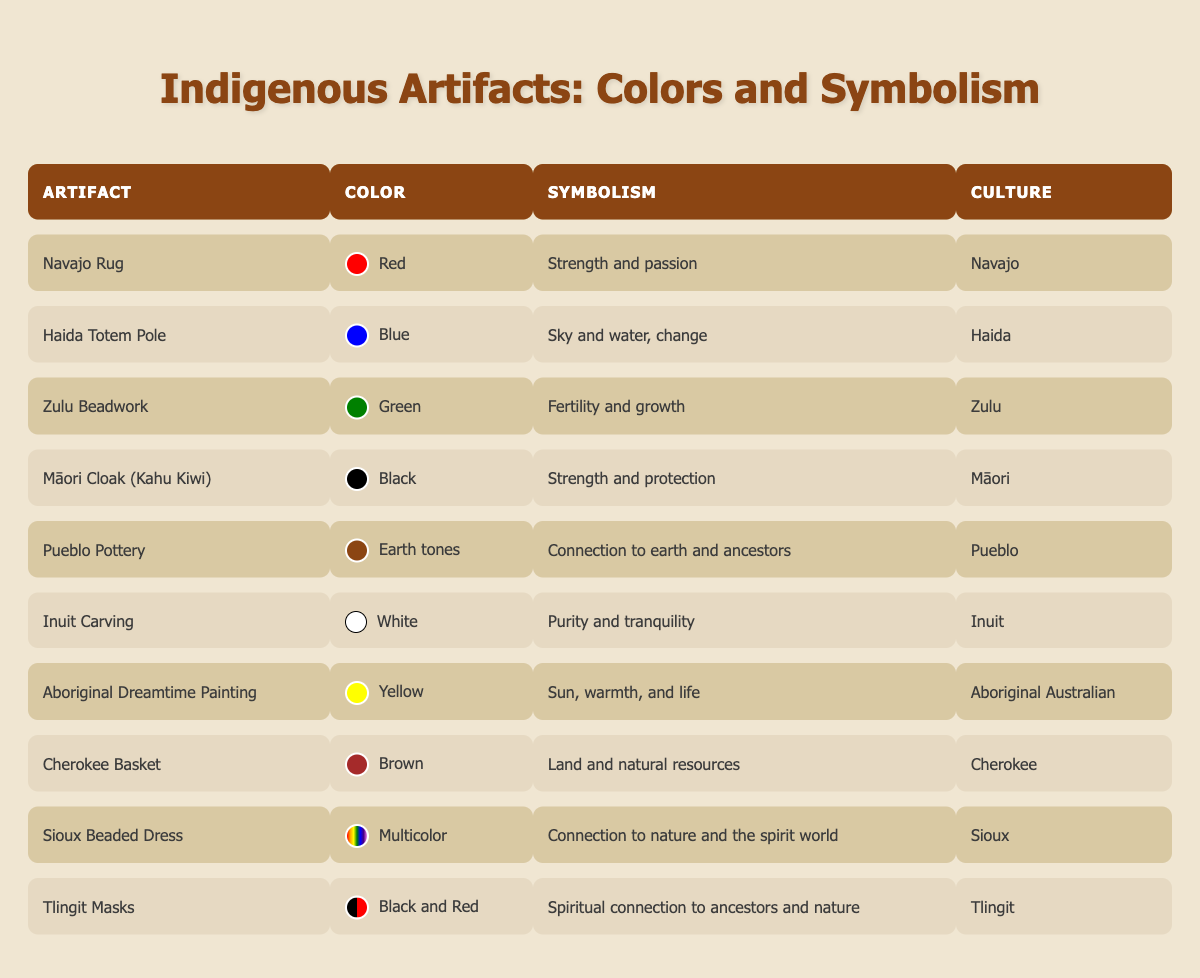What is the symbolism of the Zulu Beadwork? According to the table, the Zulu Beadwork's symbolism is "Fertility and growth."
Answer: Fertility and growth Which culture does the Māori Cloak belong to? The table indicates that the Māori Cloak (Kahu Kiwi) belongs to the Māori culture.
Answer: Māori What materials are used in the Inuit Carving? The table shows that the materials used in the Inuit Carving are either "Ivory or stone."
Answer: Ivory or stone Is the Navajo Rug used for ceremonial purposes? The table states that the Navajo Rug is used for "Blanket, ceremonial purposes," confirming that it is indeed used for ceremonial purposes.
Answer: Yes Which artifact's color symbolizes connection to earth and ancestors? The table reveals that Pueblo Pottery has the color "Earth tones," which symbolizes "Connection to earth and ancestors."
Answer: Pueblo Pottery How many different colors are represented in the artifacts? By counting the unique colors listed in the table, we have Red, Blue, Green, Black, Earth tones, White, Yellow, Brown, Multicolor, and Black and Red, giving a total of 10 distinct colors.
Answer: 10 What is the primary use of the Haida Totem Pole? The table indicates that the Haida Totem Pole is primarily used for "Cultural storytelling, memorialization."
Answer: Cultural storytelling, memorialization Which artifact has the symbolism related to the spirit world? The Sioux Beaded Dress symbolizes a "Connection to nature and the spirit world" as stated in the table.
Answer: Sioux Beaded Dress What color is associated with the Aboriginal Dreamtime Painting? The table shows that the Aboriginal Dreamtime Painting is associated with the color "Yellow."
Answer: Yellow Do both the Tlingit Masks and the Māori Cloak represent strength? The Tlingit Masks symbolize "Spiritual connection to ancestors and nature," while the Māori Cloak represents "Strength and protection," indicating only the Māori Cloak represents strength.
Answer: No 